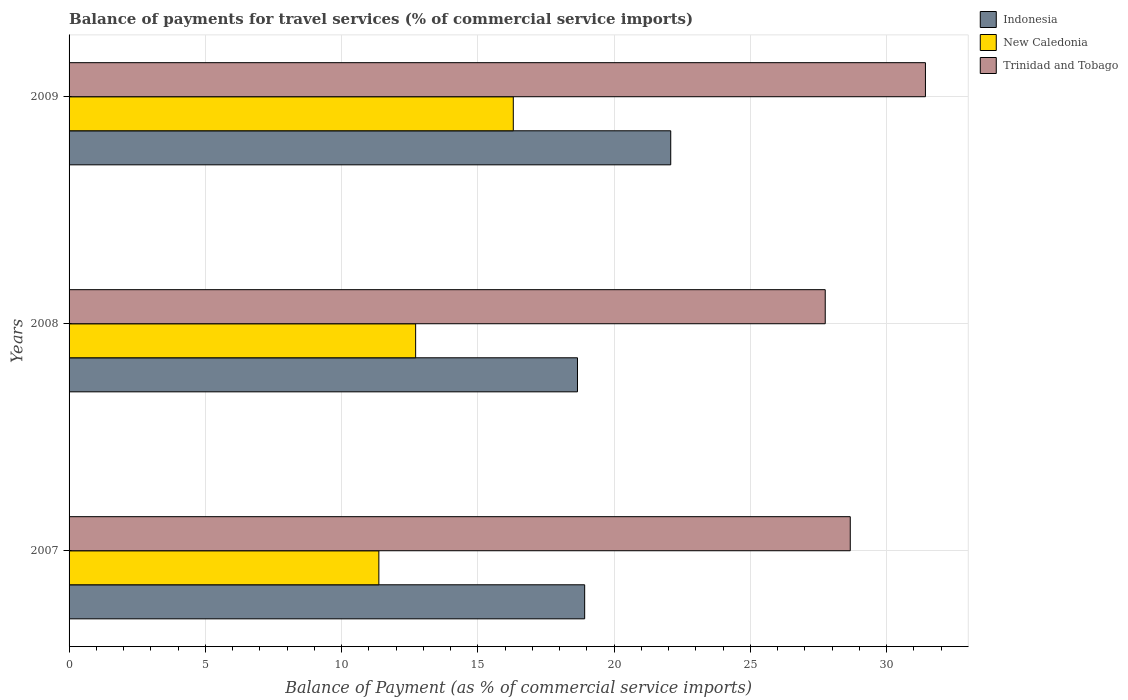How many groups of bars are there?
Your answer should be compact. 3. Are the number of bars per tick equal to the number of legend labels?
Offer a very short reply. Yes. Are the number of bars on each tick of the Y-axis equal?
Your response must be concise. Yes. How many bars are there on the 2nd tick from the top?
Your answer should be compact. 3. How many bars are there on the 3rd tick from the bottom?
Keep it short and to the point. 3. In how many cases, is the number of bars for a given year not equal to the number of legend labels?
Keep it short and to the point. 0. What is the balance of payments for travel services in Indonesia in 2008?
Ensure brevity in your answer.  18.65. Across all years, what is the maximum balance of payments for travel services in Trinidad and Tobago?
Provide a succinct answer. 31.42. Across all years, what is the minimum balance of payments for travel services in New Caledonia?
Your response must be concise. 11.37. What is the total balance of payments for travel services in New Caledonia in the graph?
Keep it short and to the point. 40.38. What is the difference between the balance of payments for travel services in Indonesia in 2008 and that in 2009?
Offer a terse response. -3.42. What is the difference between the balance of payments for travel services in New Caledonia in 2008 and the balance of payments for travel services in Trinidad and Tobago in 2007?
Your answer should be compact. -15.95. What is the average balance of payments for travel services in Trinidad and Tobago per year?
Provide a succinct answer. 29.28. In the year 2008, what is the difference between the balance of payments for travel services in New Caledonia and balance of payments for travel services in Indonesia?
Keep it short and to the point. -5.94. What is the ratio of the balance of payments for travel services in Indonesia in 2007 to that in 2008?
Offer a terse response. 1.01. Is the balance of payments for travel services in New Caledonia in 2007 less than that in 2008?
Provide a short and direct response. Yes. What is the difference between the highest and the second highest balance of payments for travel services in New Caledonia?
Give a very brief answer. 3.58. What is the difference between the highest and the lowest balance of payments for travel services in Trinidad and Tobago?
Ensure brevity in your answer.  3.68. In how many years, is the balance of payments for travel services in Indonesia greater than the average balance of payments for travel services in Indonesia taken over all years?
Provide a succinct answer. 1. What does the 3rd bar from the top in 2008 represents?
Your answer should be compact. Indonesia. What does the 3rd bar from the bottom in 2007 represents?
Offer a very short reply. Trinidad and Tobago. Is it the case that in every year, the sum of the balance of payments for travel services in New Caledonia and balance of payments for travel services in Indonesia is greater than the balance of payments for travel services in Trinidad and Tobago?
Keep it short and to the point. Yes. How many bars are there?
Your response must be concise. 9. How many years are there in the graph?
Provide a short and direct response. 3. Are the values on the major ticks of X-axis written in scientific E-notation?
Provide a short and direct response. No. Does the graph contain grids?
Provide a succinct answer. Yes. How many legend labels are there?
Offer a terse response. 3. How are the legend labels stacked?
Keep it short and to the point. Vertical. What is the title of the graph?
Make the answer very short. Balance of payments for travel services (% of commercial service imports). What is the label or title of the X-axis?
Your answer should be very brief. Balance of Payment (as % of commercial service imports). What is the Balance of Payment (as % of commercial service imports) of Indonesia in 2007?
Provide a succinct answer. 18.92. What is the Balance of Payment (as % of commercial service imports) in New Caledonia in 2007?
Ensure brevity in your answer.  11.37. What is the Balance of Payment (as % of commercial service imports) of Trinidad and Tobago in 2007?
Your answer should be very brief. 28.66. What is the Balance of Payment (as % of commercial service imports) in Indonesia in 2008?
Make the answer very short. 18.65. What is the Balance of Payment (as % of commercial service imports) in New Caledonia in 2008?
Your response must be concise. 12.72. What is the Balance of Payment (as % of commercial service imports) in Trinidad and Tobago in 2008?
Keep it short and to the point. 27.75. What is the Balance of Payment (as % of commercial service imports) in Indonesia in 2009?
Your response must be concise. 22.08. What is the Balance of Payment (as % of commercial service imports) in New Caledonia in 2009?
Your answer should be compact. 16.3. What is the Balance of Payment (as % of commercial service imports) of Trinidad and Tobago in 2009?
Your response must be concise. 31.42. Across all years, what is the maximum Balance of Payment (as % of commercial service imports) in Indonesia?
Make the answer very short. 22.08. Across all years, what is the maximum Balance of Payment (as % of commercial service imports) of New Caledonia?
Your answer should be very brief. 16.3. Across all years, what is the maximum Balance of Payment (as % of commercial service imports) of Trinidad and Tobago?
Your response must be concise. 31.42. Across all years, what is the minimum Balance of Payment (as % of commercial service imports) in Indonesia?
Provide a short and direct response. 18.65. Across all years, what is the minimum Balance of Payment (as % of commercial service imports) of New Caledonia?
Offer a very short reply. 11.37. Across all years, what is the minimum Balance of Payment (as % of commercial service imports) of Trinidad and Tobago?
Provide a succinct answer. 27.75. What is the total Balance of Payment (as % of commercial service imports) of Indonesia in the graph?
Offer a very short reply. 59.65. What is the total Balance of Payment (as % of commercial service imports) in New Caledonia in the graph?
Offer a terse response. 40.38. What is the total Balance of Payment (as % of commercial service imports) of Trinidad and Tobago in the graph?
Give a very brief answer. 87.83. What is the difference between the Balance of Payment (as % of commercial service imports) in Indonesia in 2007 and that in 2008?
Your response must be concise. 0.26. What is the difference between the Balance of Payment (as % of commercial service imports) of New Caledonia in 2007 and that in 2008?
Your response must be concise. -1.35. What is the difference between the Balance of Payment (as % of commercial service imports) in Trinidad and Tobago in 2007 and that in 2008?
Keep it short and to the point. 0.92. What is the difference between the Balance of Payment (as % of commercial service imports) in Indonesia in 2007 and that in 2009?
Your response must be concise. -3.16. What is the difference between the Balance of Payment (as % of commercial service imports) of New Caledonia in 2007 and that in 2009?
Provide a short and direct response. -4.93. What is the difference between the Balance of Payment (as % of commercial service imports) of Trinidad and Tobago in 2007 and that in 2009?
Offer a terse response. -2.76. What is the difference between the Balance of Payment (as % of commercial service imports) in Indonesia in 2008 and that in 2009?
Your answer should be very brief. -3.42. What is the difference between the Balance of Payment (as % of commercial service imports) in New Caledonia in 2008 and that in 2009?
Provide a short and direct response. -3.58. What is the difference between the Balance of Payment (as % of commercial service imports) in Trinidad and Tobago in 2008 and that in 2009?
Offer a terse response. -3.68. What is the difference between the Balance of Payment (as % of commercial service imports) in Indonesia in 2007 and the Balance of Payment (as % of commercial service imports) in New Caledonia in 2008?
Offer a terse response. 6.2. What is the difference between the Balance of Payment (as % of commercial service imports) in Indonesia in 2007 and the Balance of Payment (as % of commercial service imports) in Trinidad and Tobago in 2008?
Your response must be concise. -8.83. What is the difference between the Balance of Payment (as % of commercial service imports) of New Caledonia in 2007 and the Balance of Payment (as % of commercial service imports) of Trinidad and Tobago in 2008?
Make the answer very short. -16.38. What is the difference between the Balance of Payment (as % of commercial service imports) in Indonesia in 2007 and the Balance of Payment (as % of commercial service imports) in New Caledonia in 2009?
Give a very brief answer. 2.62. What is the difference between the Balance of Payment (as % of commercial service imports) in Indonesia in 2007 and the Balance of Payment (as % of commercial service imports) in Trinidad and Tobago in 2009?
Make the answer very short. -12.5. What is the difference between the Balance of Payment (as % of commercial service imports) of New Caledonia in 2007 and the Balance of Payment (as % of commercial service imports) of Trinidad and Tobago in 2009?
Your answer should be compact. -20.05. What is the difference between the Balance of Payment (as % of commercial service imports) of Indonesia in 2008 and the Balance of Payment (as % of commercial service imports) of New Caledonia in 2009?
Offer a terse response. 2.36. What is the difference between the Balance of Payment (as % of commercial service imports) in Indonesia in 2008 and the Balance of Payment (as % of commercial service imports) in Trinidad and Tobago in 2009?
Provide a succinct answer. -12.77. What is the difference between the Balance of Payment (as % of commercial service imports) of New Caledonia in 2008 and the Balance of Payment (as % of commercial service imports) of Trinidad and Tobago in 2009?
Offer a terse response. -18.71. What is the average Balance of Payment (as % of commercial service imports) of Indonesia per year?
Your response must be concise. 19.88. What is the average Balance of Payment (as % of commercial service imports) in New Caledonia per year?
Keep it short and to the point. 13.46. What is the average Balance of Payment (as % of commercial service imports) of Trinidad and Tobago per year?
Your response must be concise. 29.28. In the year 2007, what is the difference between the Balance of Payment (as % of commercial service imports) in Indonesia and Balance of Payment (as % of commercial service imports) in New Caledonia?
Offer a very short reply. 7.55. In the year 2007, what is the difference between the Balance of Payment (as % of commercial service imports) in Indonesia and Balance of Payment (as % of commercial service imports) in Trinidad and Tobago?
Your answer should be compact. -9.74. In the year 2007, what is the difference between the Balance of Payment (as % of commercial service imports) of New Caledonia and Balance of Payment (as % of commercial service imports) of Trinidad and Tobago?
Keep it short and to the point. -17.3. In the year 2008, what is the difference between the Balance of Payment (as % of commercial service imports) in Indonesia and Balance of Payment (as % of commercial service imports) in New Caledonia?
Offer a terse response. 5.94. In the year 2008, what is the difference between the Balance of Payment (as % of commercial service imports) of Indonesia and Balance of Payment (as % of commercial service imports) of Trinidad and Tobago?
Keep it short and to the point. -9.09. In the year 2008, what is the difference between the Balance of Payment (as % of commercial service imports) of New Caledonia and Balance of Payment (as % of commercial service imports) of Trinidad and Tobago?
Keep it short and to the point. -15.03. In the year 2009, what is the difference between the Balance of Payment (as % of commercial service imports) of Indonesia and Balance of Payment (as % of commercial service imports) of New Caledonia?
Your response must be concise. 5.78. In the year 2009, what is the difference between the Balance of Payment (as % of commercial service imports) in Indonesia and Balance of Payment (as % of commercial service imports) in Trinidad and Tobago?
Your answer should be very brief. -9.35. In the year 2009, what is the difference between the Balance of Payment (as % of commercial service imports) in New Caledonia and Balance of Payment (as % of commercial service imports) in Trinidad and Tobago?
Your answer should be very brief. -15.12. What is the ratio of the Balance of Payment (as % of commercial service imports) in Indonesia in 2007 to that in 2008?
Keep it short and to the point. 1.01. What is the ratio of the Balance of Payment (as % of commercial service imports) of New Caledonia in 2007 to that in 2008?
Keep it short and to the point. 0.89. What is the ratio of the Balance of Payment (as % of commercial service imports) in Trinidad and Tobago in 2007 to that in 2008?
Keep it short and to the point. 1.03. What is the ratio of the Balance of Payment (as % of commercial service imports) in Indonesia in 2007 to that in 2009?
Your answer should be very brief. 0.86. What is the ratio of the Balance of Payment (as % of commercial service imports) of New Caledonia in 2007 to that in 2009?
Give a very brief answer. 0.7. What is the ratio of the Balance of Payment (as % of commercial service imports) in Trinidad and Tobago in 2007 to that in 2009?
Provide a short and direct response. 0.91. What is the ratio of the Balance of Payment (as % of commercial service imports) in Indonesia in 2008 to that in 2009?
Provide a succinct answer. 0.84. What is the ratio of the Balance of Payment (as % of commercial service imports) in New Caledonia in 2008 to that in 2009?
Offer a very short reply. 0.78. What is the ratio of the Balance of Payment (as % of commercial service imports) in Trinidad and Tobago in 2008 to that in 2009?
Make the answer very short. 0.88. What is the difference between the highest and the second highest Balance of Payment (as % of commercial service imports) of Indonesia?
Offer a very short reply. 3.16. What is the difference between the highest and the second highest Balance of Payment (as % of commercial service imports) of New Caledonia?
Keep it short and to the point. 3.58. What is the difference between the highest and the second highest Balance of Payment (as % of commercial service imports) of Trinidad and Tobago?
Provide a succinct answer. 2.76. What is the difference between the highest and the lowest Balance of Payment (as % of commercial service imports) of Indonesia?
Provide a succinct answer. 3.42. What is the difference between the highest and the lowest Balance of Payment (as % of commercial service imports) of New Caledonia?
Give a very brief answer. 4.93. What is the difference between the highest and the lowest Balance of Payment (as % of commercial service imports) in Trinidad and Tobago?
Your answer should be very brief. 3.68. 